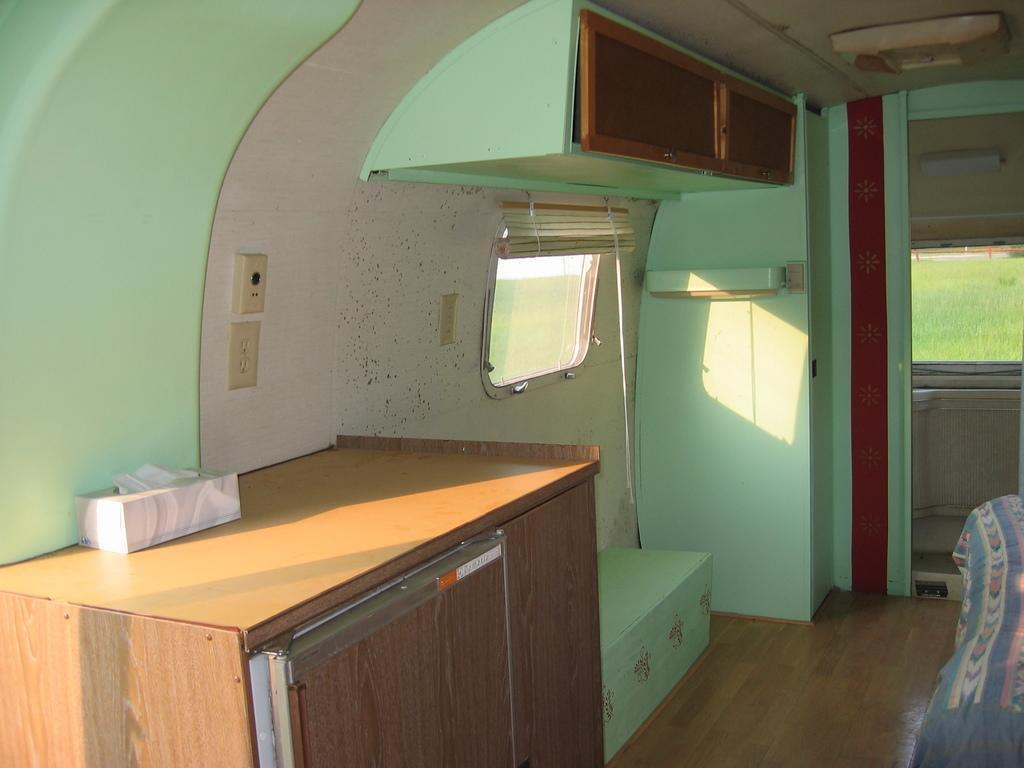How would you summarize this image in a sentence or two? In this image we can see cupboards, table, windows and bed. Lights are attached to the roof. Sockets are on the wall. Above this table there is a tissue paper box. Through this window we can see grass. 